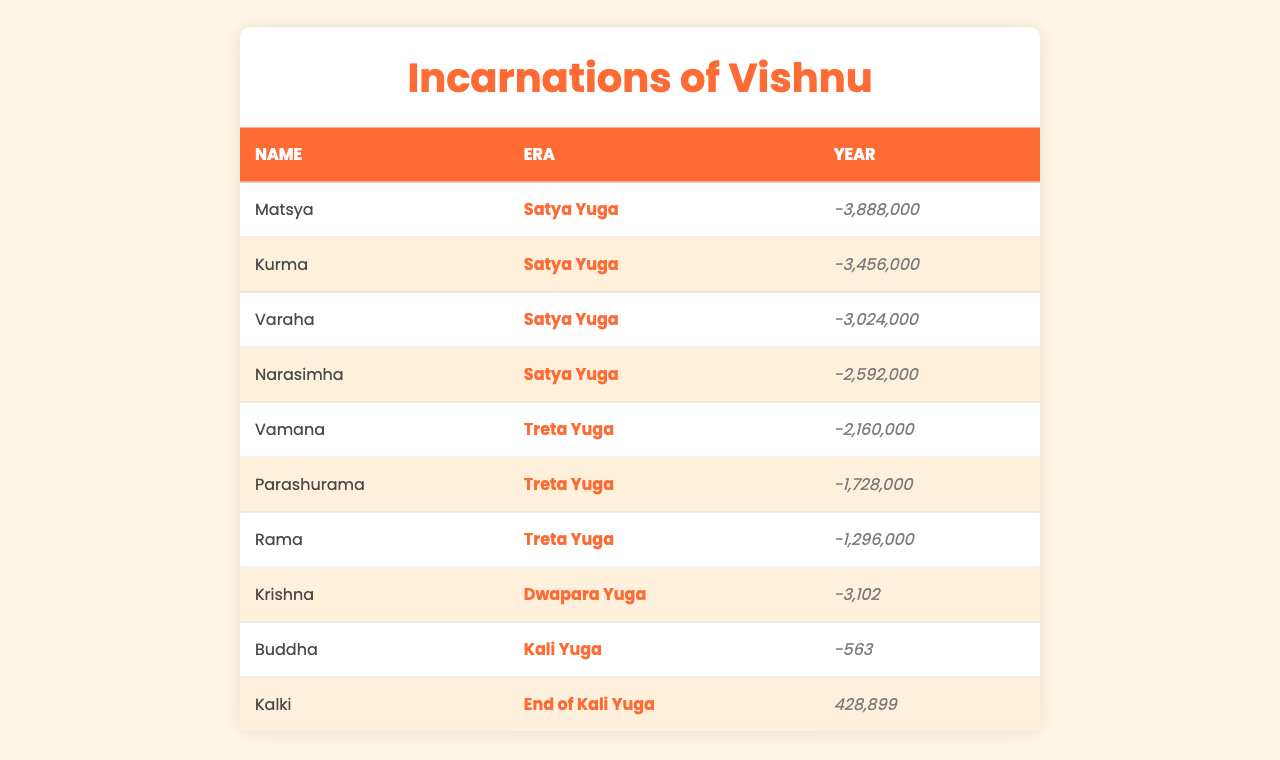What is the era of the incarnation "Rama"? The table lists "Rama" under the column labeled "Era", which indicates that "Rama" belongs to the "Treta Yuga".
Answer: Treta Yuga How many incarnations are listed in the table? By counting the number of entries in the table, we find there are 10 incarnations listed.
Answer: 10 Which incarnation corresponds to the year -1728000? We look for the entry where the "Year" column shows -1728000. This matches the incarnation "Parashurama".
Answer: Parashurama What is the difference in years between the first incarnation "Matsya" and the last incarnation "Kalki"? "Matsya" is from the year -3888000 and "Kalki" is from the year 428899. The difference is -3888000 - 428899 = -4316899.
Answer: -4316899 What is the average year of the incarnations in the "Satya Yuga"? The years for "Matsya", "Kurma", "Varaha", and "Narasimha" in the "Satya Yuga" are (-3888000, -3456000, -3024000, -2592000). Adding these gives -12912000. Dividing by 4 (the number of incarnations) results in -3228000 as the average.
Answer: -3228000 Is "Krishna" the only incarnation listed from the "Dwapara Yuga"? The table has one entry for "Krishna" under "Dwapara Yuga," indicating that it is the only one in that category.
Answer: Yes Which incarnation is associated with the "Kali Yuga"? Referring to the table, we see that "Buddha" is the incarnation associated with the "Kali Yuga".
Answer: Buddha How many incarnations belong to the "Treta Yuga"? The entries for "Vamana", "Parashurama", and "Rama" all fall under the "Treta Yuga," making a total of 3 incarnations.
Answer: 3 What year did "Narasimha" appear? The year listed for "Narasimha" in the table is -2592000.
Answer: -2592000 Is "Kalki" expected to appear before the year 0? The table shows "Kalki" in the year 428899, which is after year 0.
Answer: No 